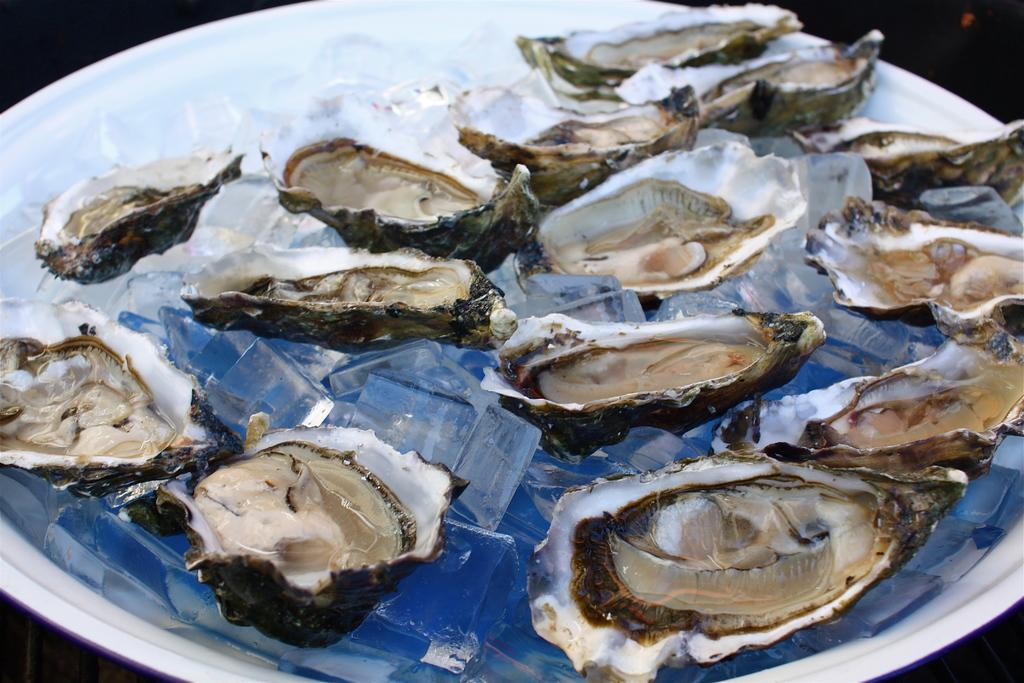What type of sea creatures are in the image? There are pearl oysters in the image. What is the container holding the pearl oysters? The image appears to show a plastic bowl. What is used to keep the pearl oysters cool in the bowl? There are ice blocks in the bowl. How many boys are walking in the spring season in the image? There are no boys or any reference to a spring season in the image; it features pearl oysters in a plastic bowl with ice blocks. 